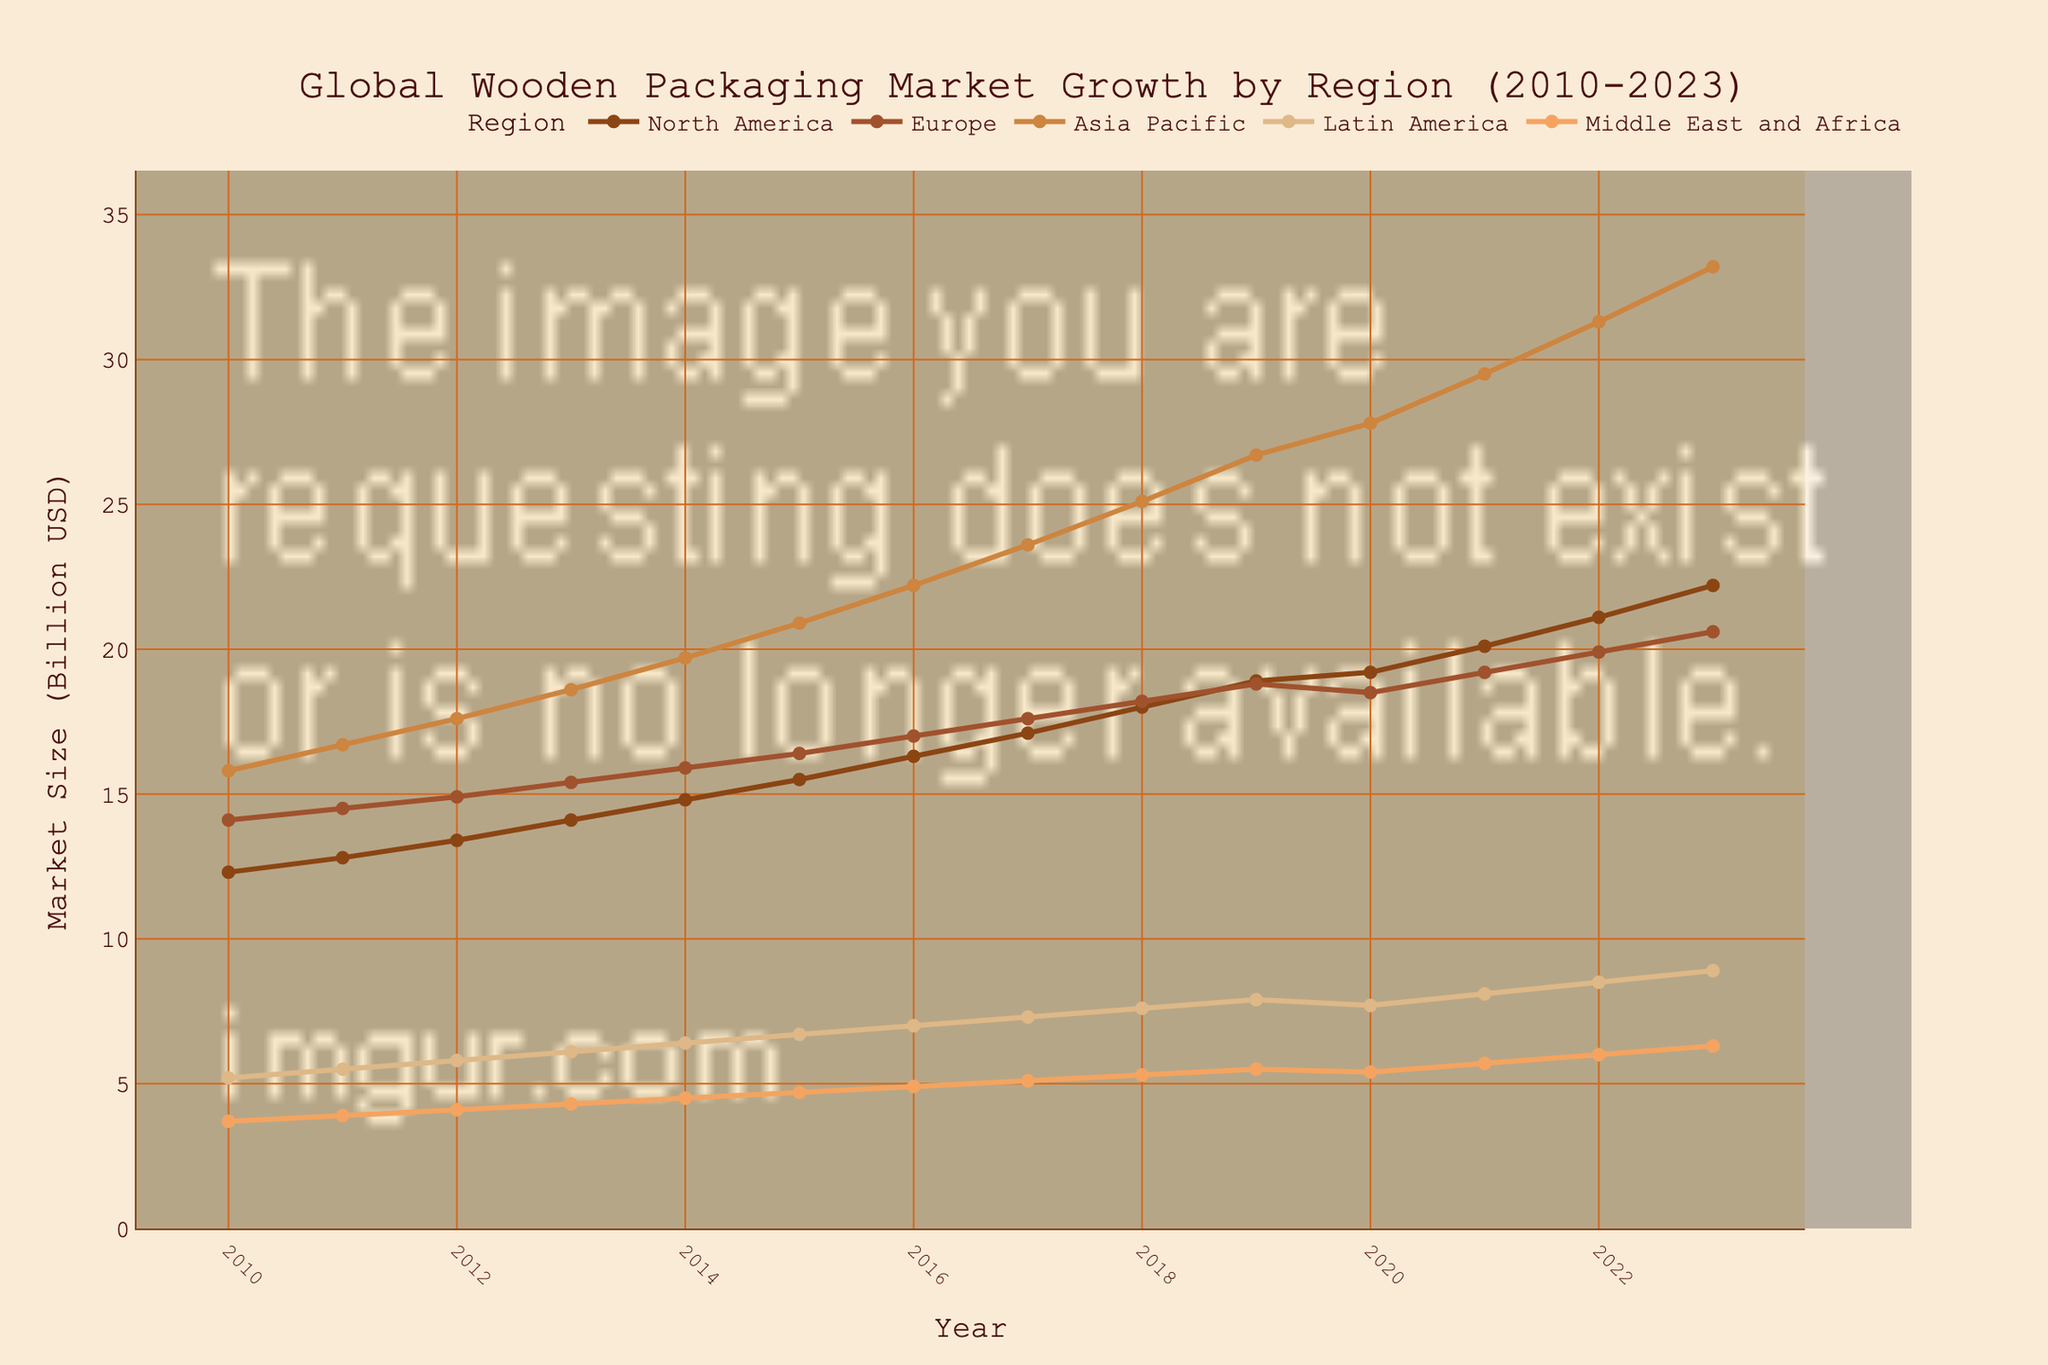What's the trend for the Asia Pacific market from 2010 to 2023? The trend for the Asia Pacific market shows a consistent increase from 15.8 billion USD in 2010 to 33.2 billion USD in 2023. This can be observed by the upward-sloping line representing the Asia Pacific region.
Answer: Consistent increase Which region had the highest market size in 2023? In 2023, the Asia Pacific region had the highest market size, as indicated by the highest point on the chart for that year.
Answer: Asia Pacific Between 2010 and 2020, which region experienced the slowest growth in market size? By comparing the slopes of the lines from 2010 to 2020, the Middle East and Africa region had the slowest growth, with the market size increasing from 3.7 billion USD in 2010 to 5.4 billion USD in 2020.
Answer: Middle East and Africa How much did the North American market grow from 2010 to 2023? The North American market grew from 12.3 billion USD in 2010 to 22.2 billion USD in 2023. The difference can be calculated as 22.2 - 12.3 = 9.9 billion USD.
Answer: 9.9 billion USD Which two regions had similar market sizes in 2020? In 2020, Europe and North America had similar market sizes, with Europe at 18.5 billion USD and North America at 19.2 billion USD.
Answer: Europe and North America In what year did the Latin American market reach 8 billion USD? By looking at the Latin America line, it intersected the 8 billion USD mark in 2021.
Answer: 2021 Which region showed the most rapid increase in market size between 2015 and 2020? The Asia Pacific region showed the most rapid increase in market size from 20.9 billion USD in 2015 to 27.8 billion USD in 2020, reflecting the steepest slope among all regions.
Answer: Asia Pacific Did any region experience a decline in market size between any two consecutive years? Yes, the Europe region experienced a slight decline between 2019 and 2020, with the market size decreasing from 18.8 billion USD to 18.5 billion USD.
Answer: Yes (Europe, 2019-2020) In 2015, how much larger was the Asia Pacific market compared to the Europe market? In 2015, the Asia Pacific market was 20.9 billion USD, and the Europe market was 16.4 billion USD. The difference is 20.9 - 16.4 = 4.5 billion USD.
Answer: 4.5 billion USD 